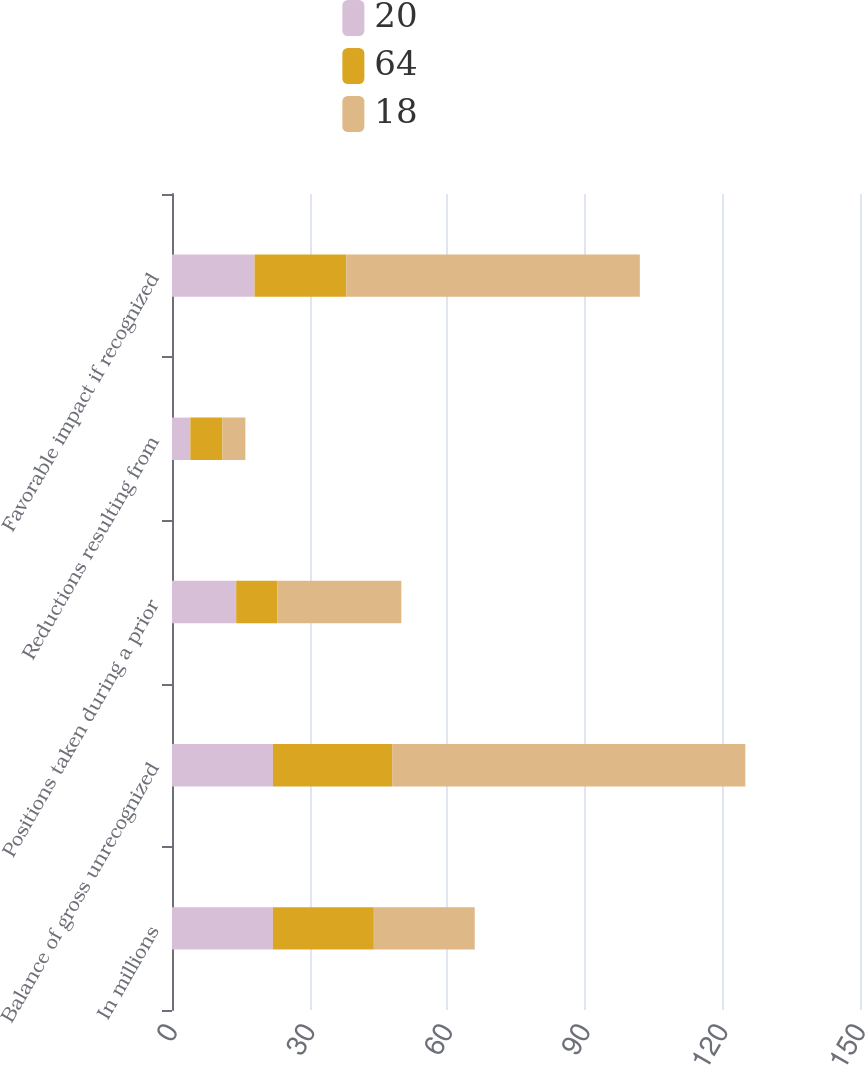Convert chart. <chart><loc_0><loc_0><loc_500><loc_500><stacked_bar_chart><ecel><fcel>In millions<fcel>Balance of gross unrecognized<fcel>Positions taken during a prior<fcel>Reductions resulting from<fcel>Favorable impact if recognized<nl><fcel>20<fcel>22<fcel>22<fcel>14<fcel>4<fcel>18<nl><fcel>64<fcel>22<fcel>26<fcel>9<fcel>7<fcel>20<nl><fcel>18<fcel>22<fcel>77<fcel>27<fcel>5<fcel>64<nl></chart> 